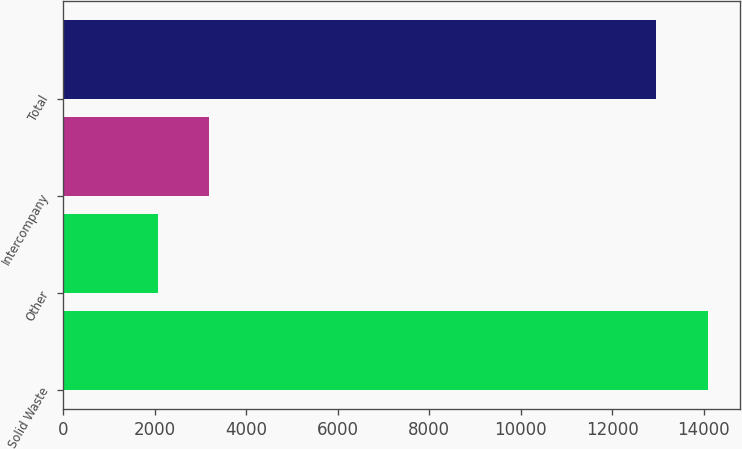<chart> <loc_0><loc_0><loc_500><loc_500><bar_chart><fcel>Solid Waste<fcel>Other<fcel>Intercompany<fcel>Total<nl><fcel>14083<fcel>2065<fcel>3187<fcel>12961<nl></chart> 